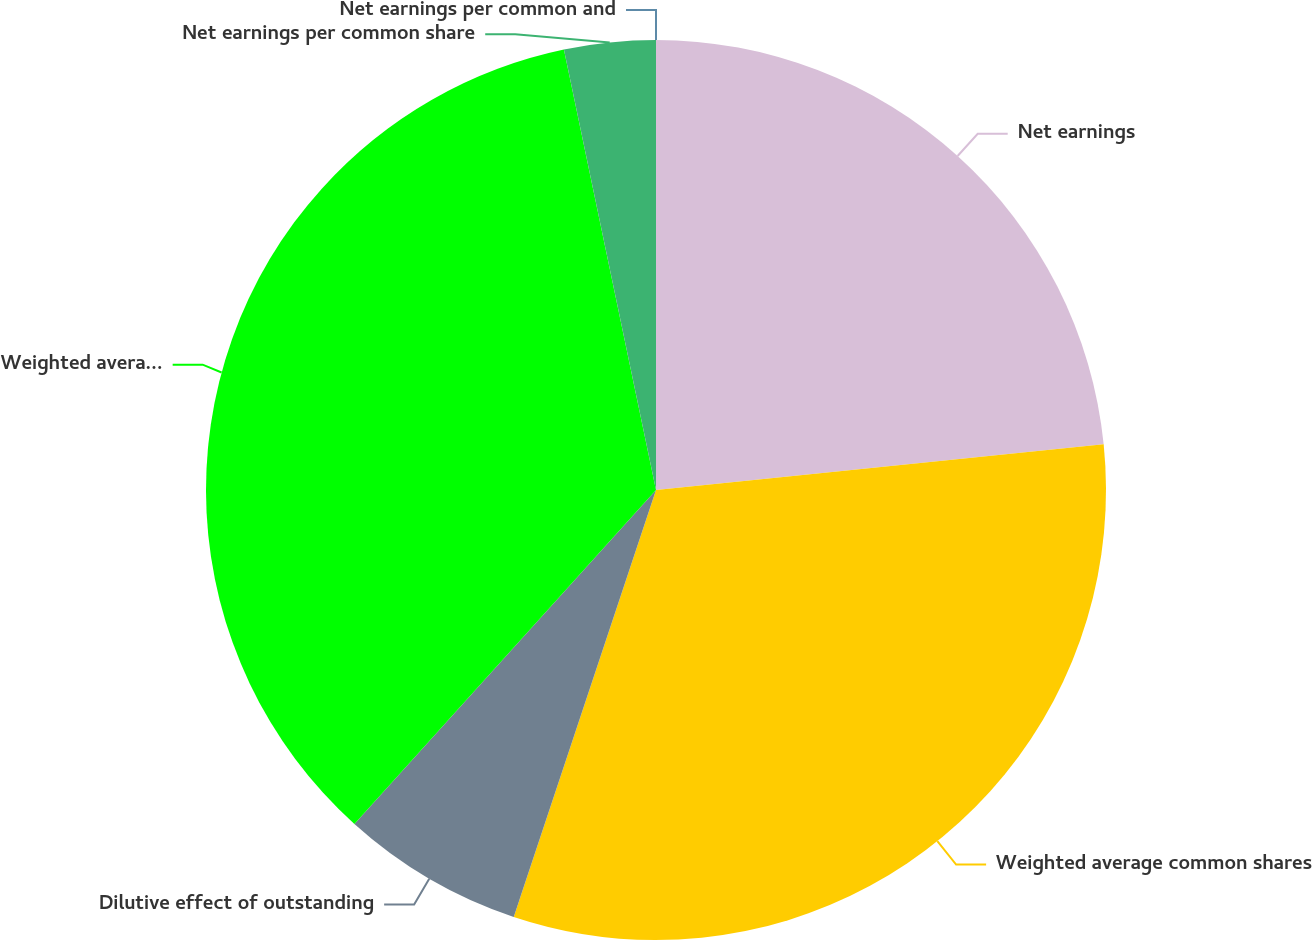Convert chart to OTSL. <chart><loc_0><loc_0><loc_500><loc_500><pie_chart><fcel>Net earnings<fcel>Weighted average common shares<fcel>Dilutive effect of outstanding<fcel>Weighted average common and<fcel>Net earnings per common share<fcel>Net earnings per common and<nl><fcel>23.38%<fcel>31.74%<fcel>6.57%<fcel>35.03%<fcel>3.28%<fcel>0.0%<nl></chart> 